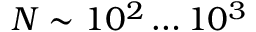<formula> <loc_0><loc_0><loc_500><loc_500>N \sim 1 0 ^ { 2 } \dots 1 0 ^ { 3 }</formula> 